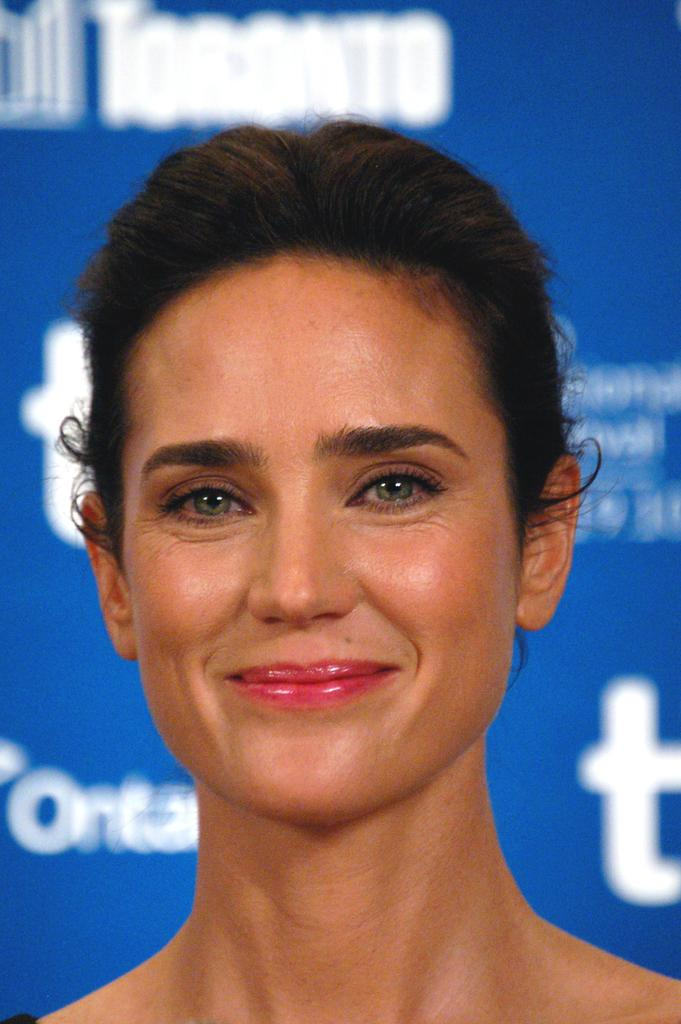Who or what is present in the image? There is a person in the image. What can be seen in the background of the image? There is a blue colored board with text in the background of the image. What type of hose is being used by the person in the image? There is no hose present in the image. What type of gun is the person holding in the image? There is no gun present in the image. 